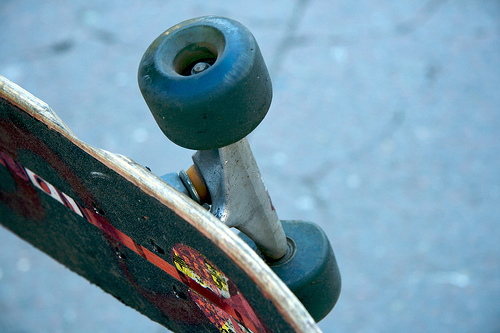<image>
Is the wheel on the skateboard? Yes. Looking at the image, I can see the wheel is positioned on top of the skateboard, with the skateboard providing support. 